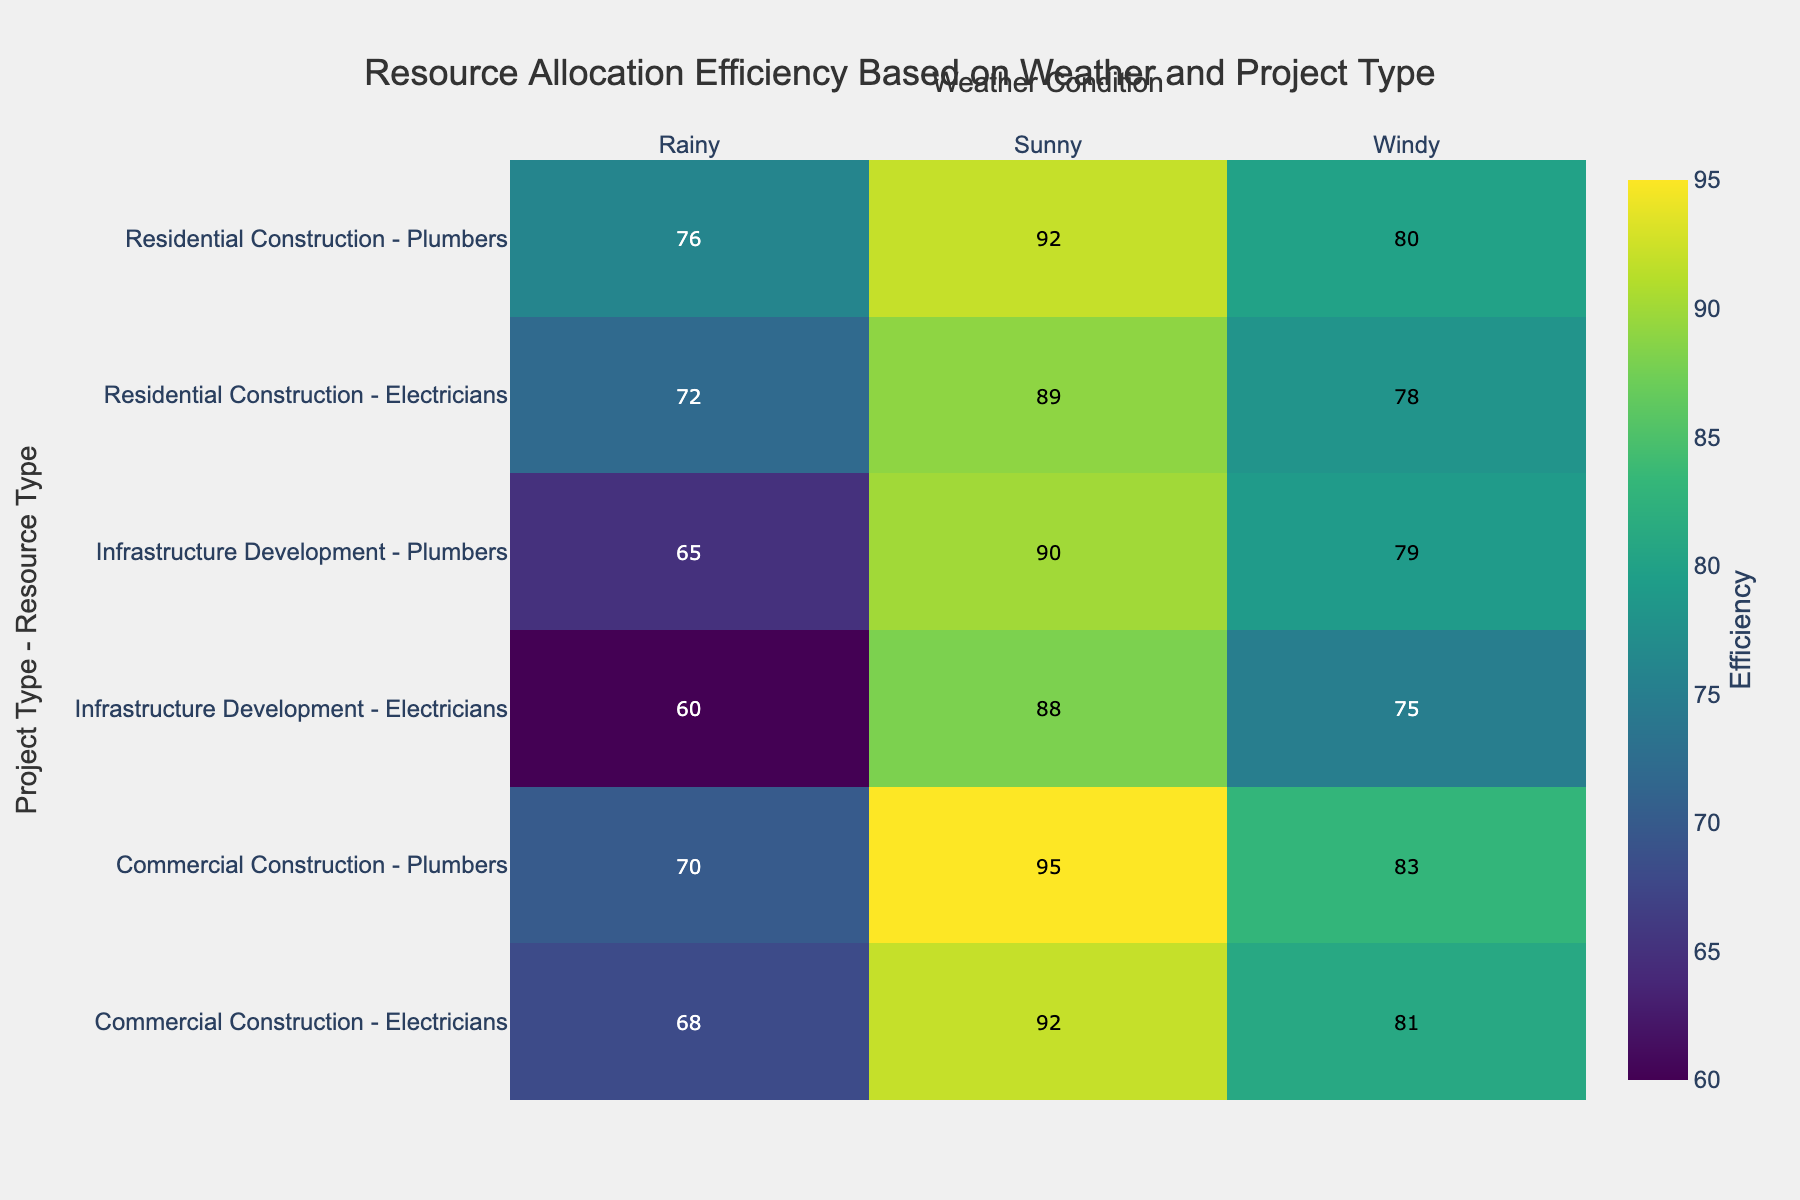What's the title of the heatmap? The title is displayed at the top center of the heatmap in bold fonts. It indicates the main topic or focus of the figure. Here, it reads 'Resource Allocation Efficiency Based on Weather and Project Type'.
Answer: Resource Allocation Efficiency Based on Weather and Project Type What are the weather conditions shown in the heatmap? The weather conditions are displayed along the top axis of the heatmap. They are 'Sunny', 'Rainy', and 'Windy'.
Answer: Sunny, Rainy, Windy What is the highest efficiency value, and under which conditions and project type/resource type was it recorded? The highest efficiency value is represented by the darkest color (close to yellow) on the heatmap. By examining the corresponding row and column, it can be identified as 95 under 'Sunny' conditions for 'Commercial Construction - Plumbers'.
Answer: 95, Sunny, Commercial Construction - Plumbers What is the efficiency of Electricians in Commercial Construction during Rainy conditions? Locate the row for 'Commercial Construction - Electricians' and follow it to the column under 'Rainy'. The number displayed there represents the efficiency.
Answer: 68 Which project type and resource type combination has the lowest efficiency in Rainy conditions? By examining the color gradient, look for the lightest color in the 'Rainy' column. The lowest efficiency is 60, observed for 'Infrastructure Development - Electricians'.
Answer: Infrastructure Development - Electricians How does the efficiency of Plumbers in Residential Construction compare between Sunny and Windy conditions? Find the row for 'Residential Construction - Plumbers' and compare the values under 'Sunny' and 'Windy' columns. The efficiency values are 92 and 80, respectively.
Answer: Efficiency is higher in Sunny (92) than in Windy (80) Which project type shows the highest average efficiency under Sunny conditions? Calculate the average efficiency for each project type under 'Sunny':  
Residential Construction: (92+89)/2 = 90.5  
Commercial Construction: (95+92)/2 = 93.5  
Infrastructure Development: (90+88)/2 = 89  
The highest average is 93.5 for Commercial Construction.
Answer: Commercial Construction What is the difference in efficiency between Plumbers and Electricians in Infrastructure Development under Windy conditions? Locate the 'Windy' column for 'Infrastructure Development - Plumbers' and 'Infrastructure Development - Electricians', then subtract the efficiency values (79 - 75).
Answer: 4 Which resource type in Commercial Construction is most affected by Rainy conditions? Compare the efficiency drop for both resource types from Sunny to Rainy.  
Plumbers: 95 (Sunny) to 70 (Rainy) = 25  
Electricians: 92 (Sunny) to 68 (Rainy) = 24  
The largest drop is for Plumbers with a reduction of 25.
Answer: Plumbers What is the color scale used to represent the efficiency values in this heatmap? The heatmap uses a 'Viridis' color scale, where lower efficiencies are represented with darker colors (purples) and higher efficiencies with lighter colors (yellows).
Answer: Viridis 